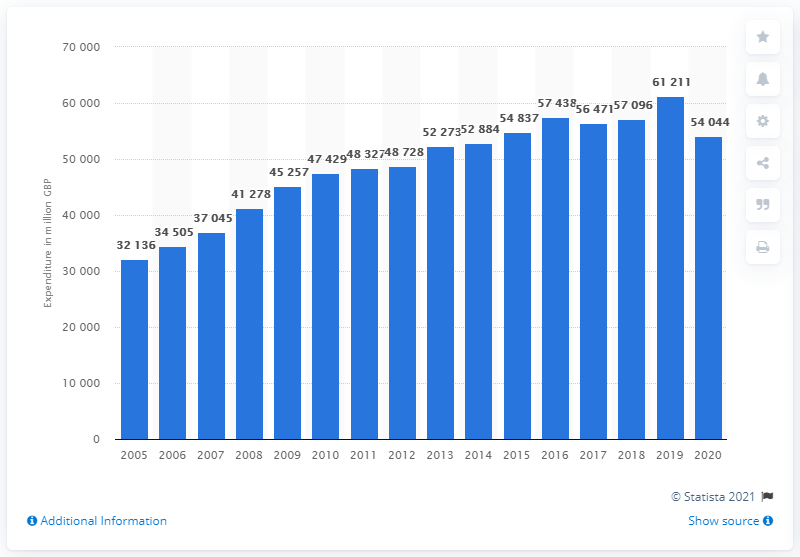Specify some key components in this picture. In 2020, the UK households purchased approximately 54,044 pounds worth of clothing. 